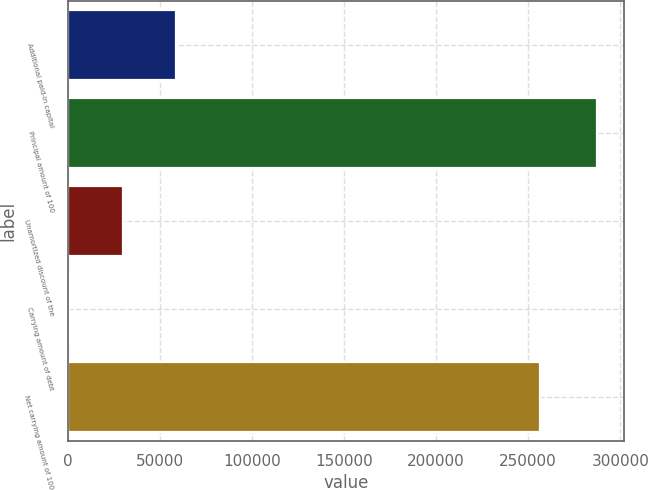Convert chart to OTSL. <chart><loc_0><loc_0><loc_500><loc_500><bar_chart><fcel>Additional paid-in capital<fcel>Principal amount of 100<fcel>Unamortized discount of the<fcel>Carrying amount of debt<fcel>Net carrying amount of 100<nl><fcel>58629.8<fcel>287500<fcel>29972<fcel>922<fcel>256606<nl></chart> 